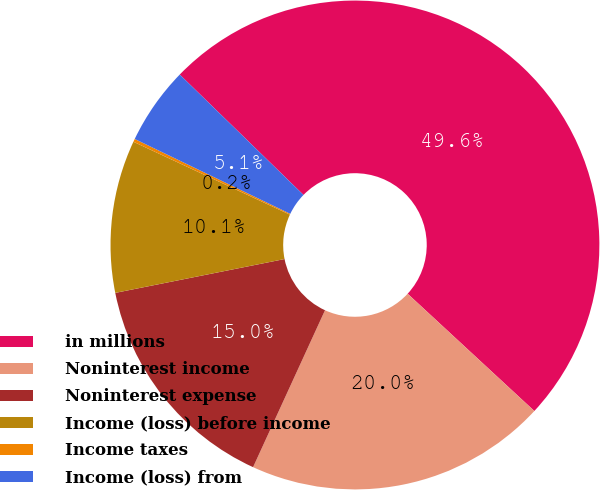Convert chart to OTSL. <chart><loc_0><loc_0><loc_500><loc_500><pie_chart><fcel>in millions<fcel>Noninterest income<fcel>Noninterest expense<fcel>Income (loss) before income<fcel>Income taxes<fcel>Income (loss) from<nl><fcel>49.61%<fcel>19.96%<fcel>15.02%<fcel>10.08%<fcel>0.2%<fcel>5.14%<nl></chart> 